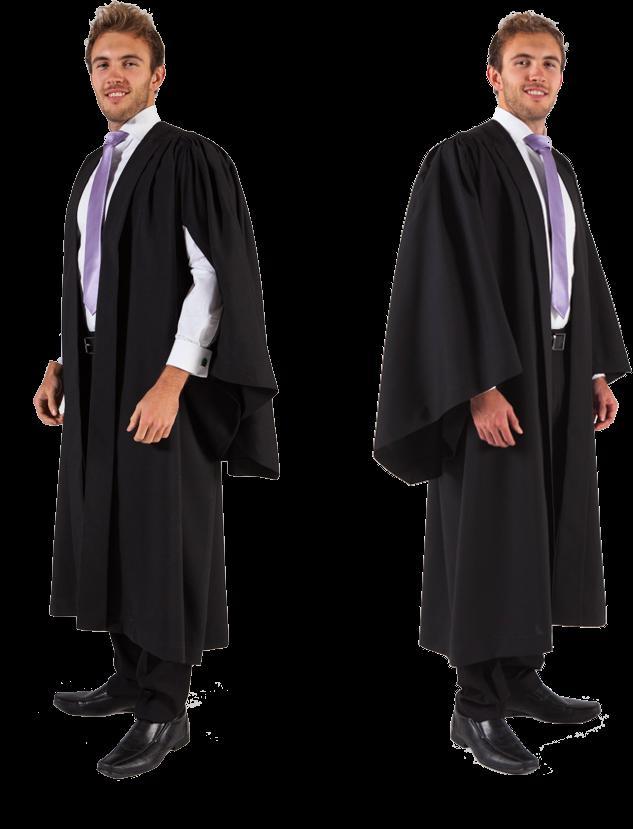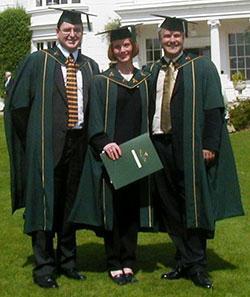The first image is the image on the left, the second image is the image on the right. Evaluate the accuracy of this statement regarding the images: "At least one gown has a long gold embellishment.". Is it true? Answer yes or no. No. 